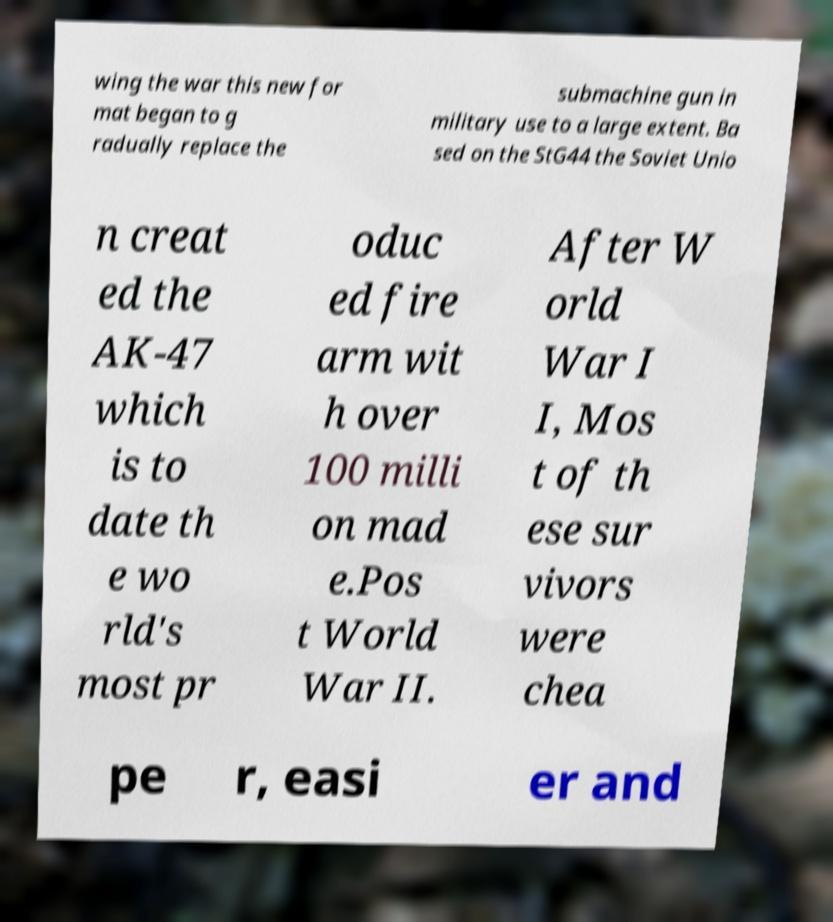Can you read and provide the text displayed in the image?This photo seems to have some interesting text. Can you extract and type it out for me? wing the war this new for mat began to g radually replace the submachine gun in military use to a large extent. Ba sed on the StG44 the Soviet Unio n creat ed the AK-47 which is to date th e wo rld's most pr oduc ed fire arm wit h over 100 milli on mad e.Pos t World War II. After W orld War I I, Mos t of th ese sur vivors were chea pe r, easi er and 